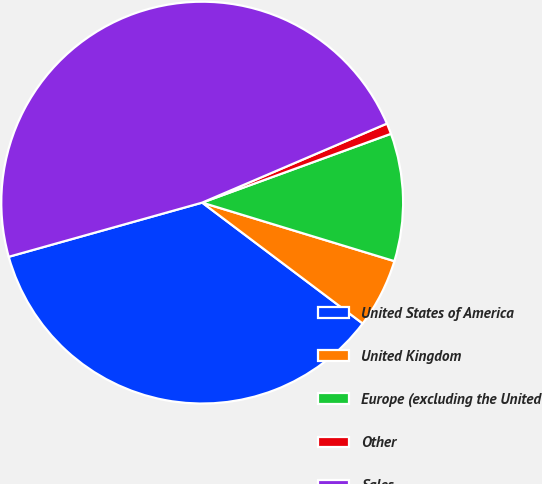Convert chart to OTSL. <chart><loc_0><loc_0><loc_500><loc_500><pie_chart><fcel>United States of America<fcel>United Kingdom<fcel>Europe (excluding the United<fcel>Other<fcel>Sales<nl><fcel>35.38%<fcel>5.57%<fcel>10.27%<fcel>0.87%<fcel>47.91%<nl></chart> 